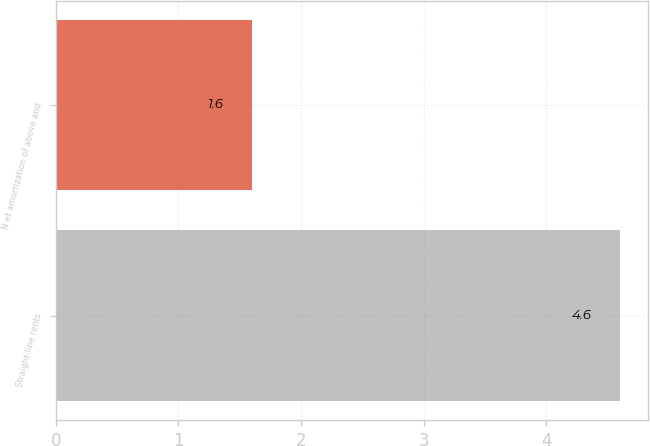Convert chart to OTSL. <chart><loc_0><loc_0><loc_500><loc_500><bar_chart><fcel>Straight-line rents<fcel>N et amortization of above and<nl><fcel>4.6<fcel>1.6<nl></chart> 